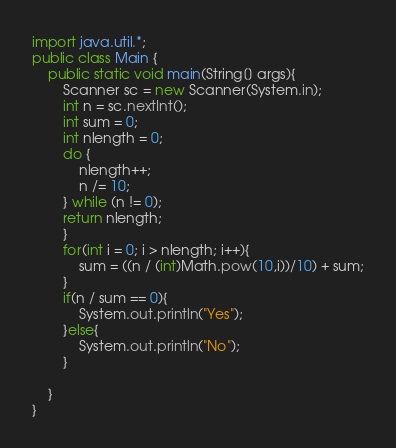Convert code to text. <code><loc_0><loc_0><loc_500><loc_500><_Java_>import java.util.*;
public class Main {
    public static void main(String[] args){
        Scanner sc = new Scanner(System.in);
        int n = sc.nextInt();
        int sum = 0;
        int nlength = 0;
        do {
            nlength++;
            n /= 10;
        } while (n != 0);
        return nlength;
        }   
        for(int i = 0; i > nlength; i++){
            sum = ((n / (int)Math.pow(10,i))/10) + sum;
        }
        if(n / sum == 0){
            System.out.println("Yes");
        }else{
            System.out.println("No");
        }
        
    }
}</code> 